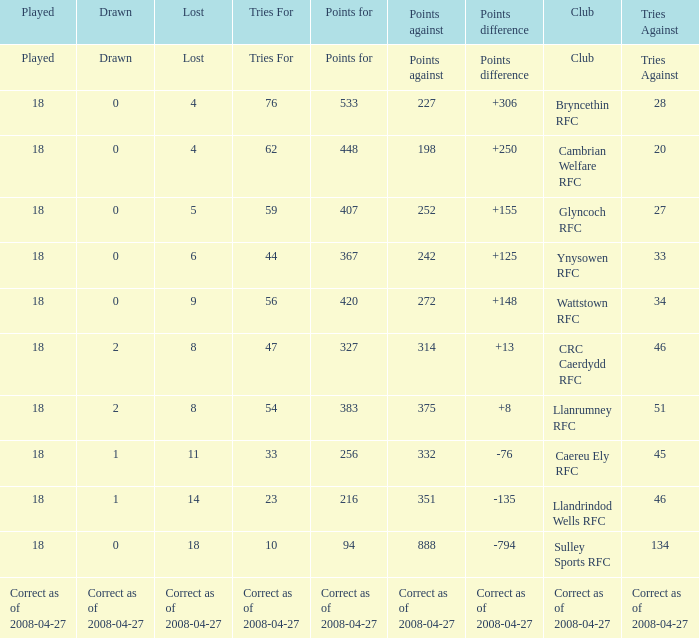What is the value for the item "Lost" when the value "Tries" is 47? 8.0. 